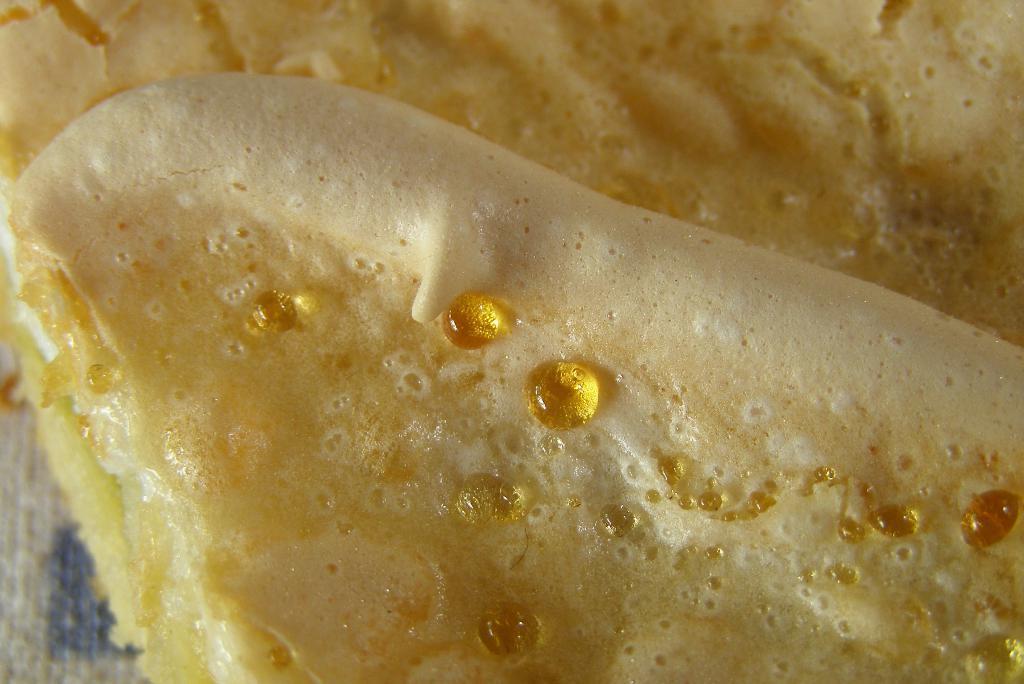How would you summarize this image in a sentence or two? In this image I can see a bread on the table. This image is taken may be in a room. 